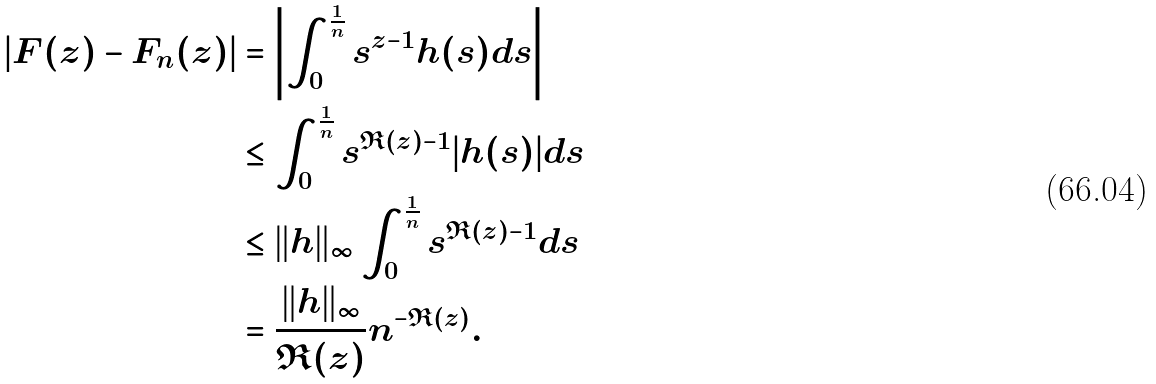Convert formula to latex. <formula><loc_0><loc_0><loc_500><loc_500>| F ( z ) - F _ { n } ( z ) | & = \left | \int _ { 0 } ^ { \frac { 1 } { n } } s ^ { z - 1 } h ( s ) d s \right | \\ & \leq \int _ { 0 } ^ { \frac { 1 } { n } } s ^ { \Re ( z ) - 1 } | h ( s ) | d s \\ & \leq \| h \| _ { \infty } \int _ { 0 } ^ { \frac { 1 } { n } } s ^ { \Re ( z ) - 1 } d s \\ & = \frac { \| h \| _ { \infty } } { \Re ( z ) } n ^ { - \Re ( z ) } .</formula> 